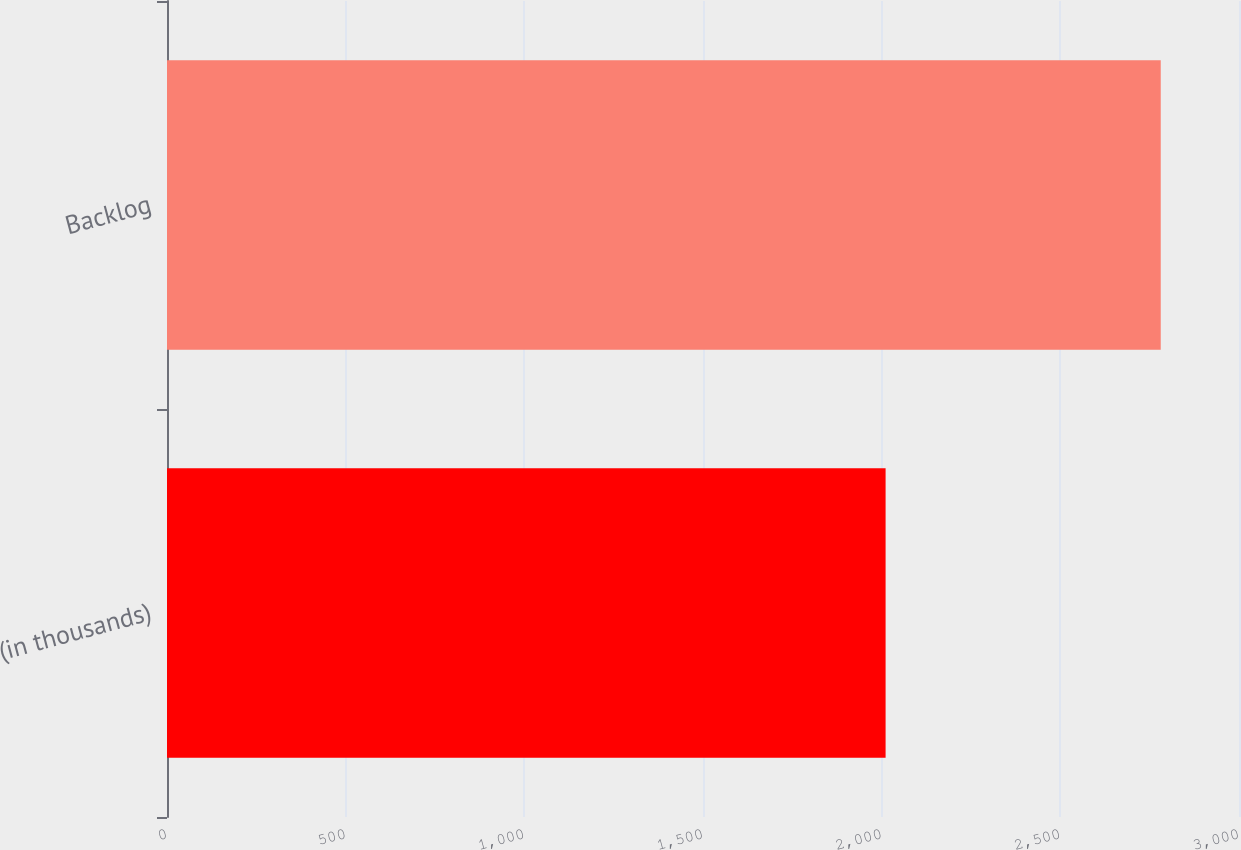<chart> <loc_0><loc_0><loc_500><loc_500><bar_chart><fcel>(in thousands)<fcel>Backlog<nl><fcel>2011<fcel>2781<nl></chart> 